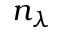Convert formula to latex. <formula><loc_0><loc_0><loc_500><loc_500>n _ { \lambda }</formula> 